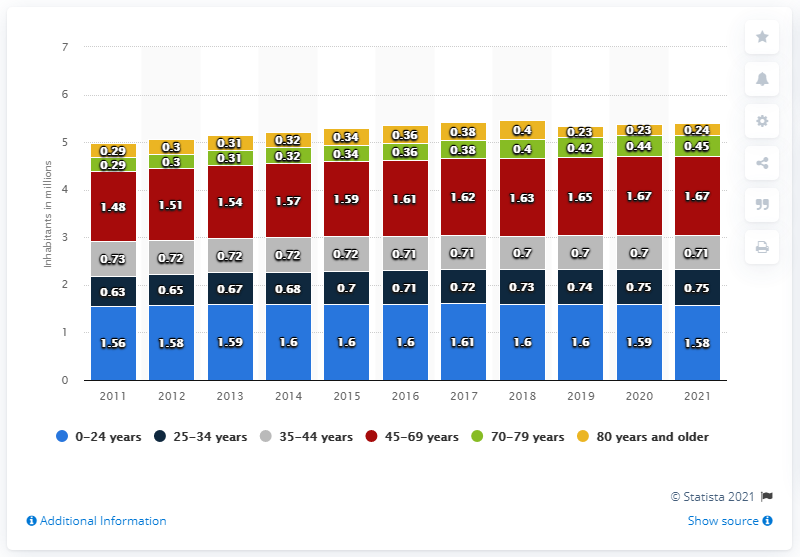List a handful of essential elements in this visual. In 2021, the number of individuals in the youngest age group in Norway was approximately 1.58 million. In 2021, Norway's largest age group between 45 and 69 years old was 1,670,000 people. 